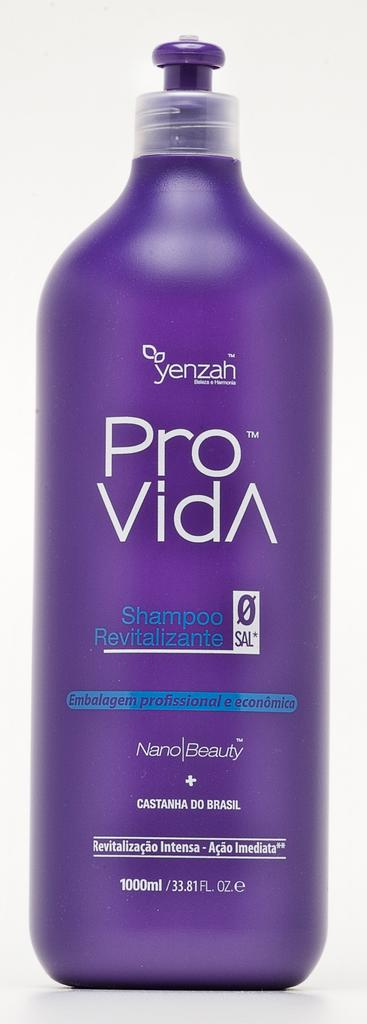What type of product is featured in the image? There is a shampoo bottle in the image. What is the name of the shampoo brand? The shampoo bottle has the name "pro vida". What color is the shampoo bottle? The shampoo bottle is blue in color. How many dogs are visible in the image? There are no dogs present in the image. What type of plastic is the shampoo bottle made of? The facts provided do not mention the material of the shampoo bottle, so we cannot determine if it is made of plastic or not. 